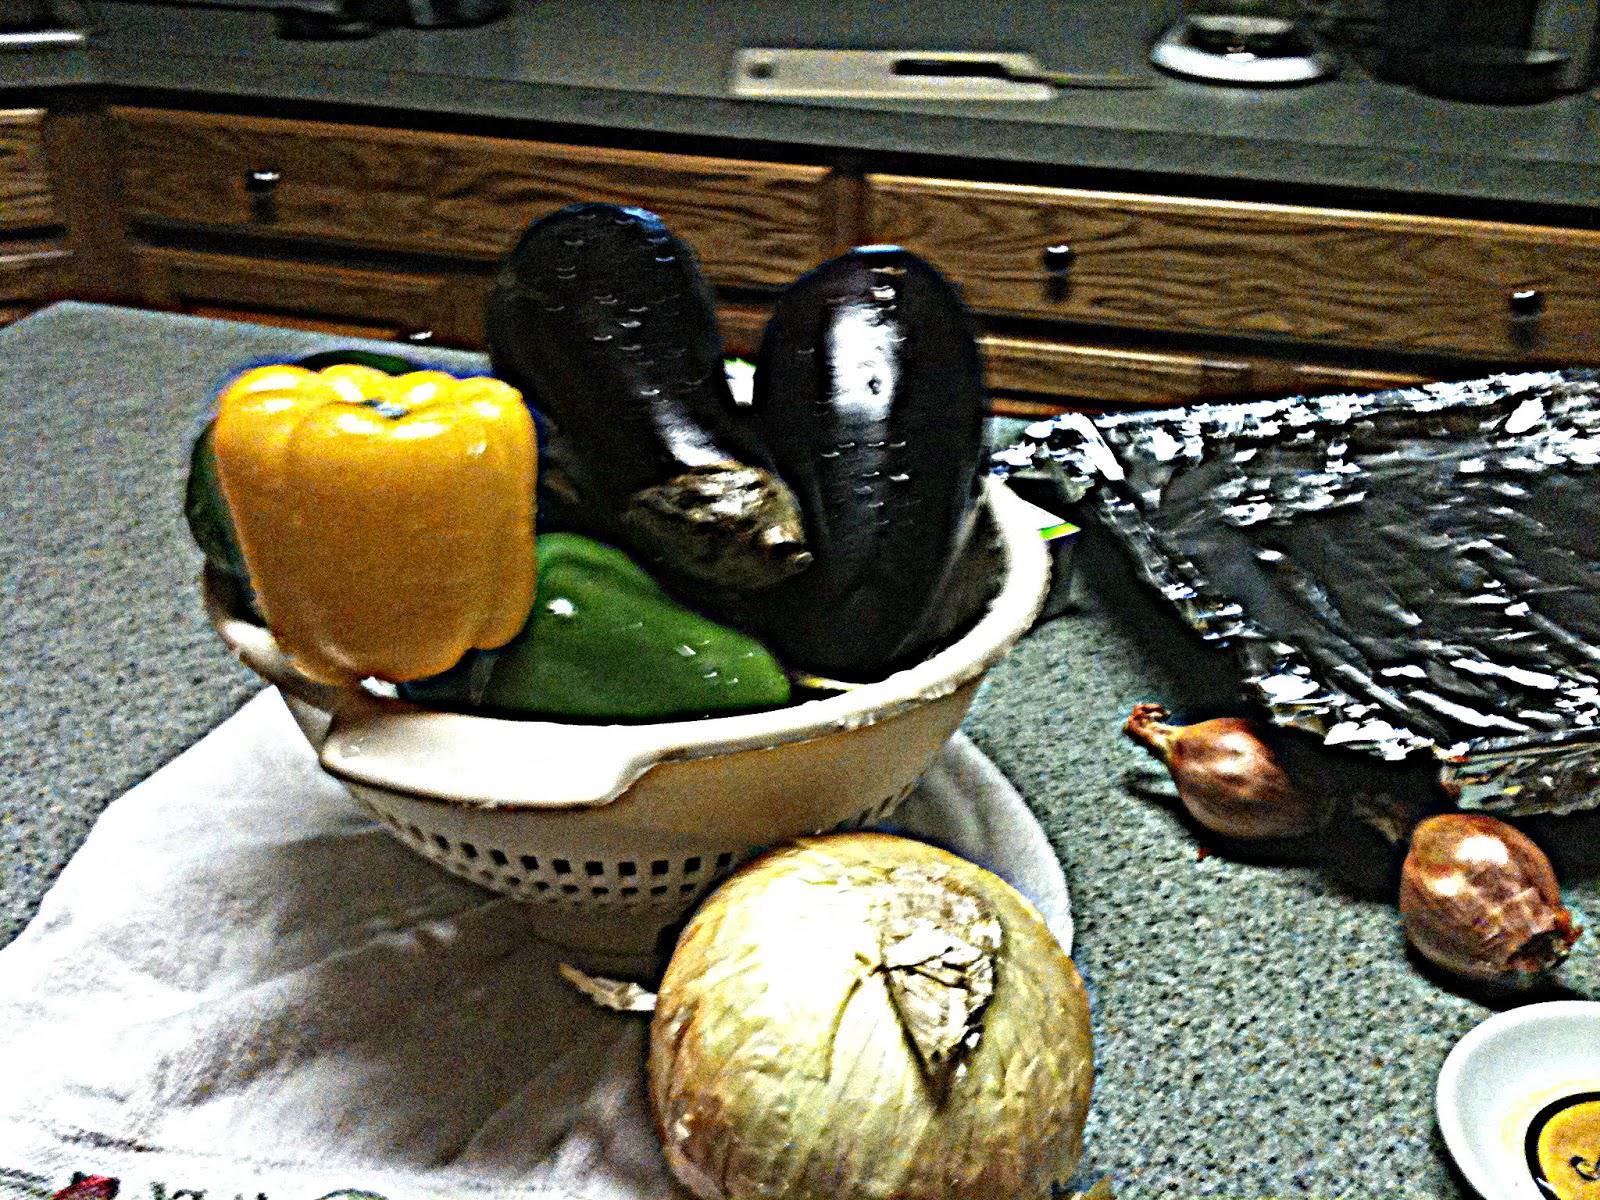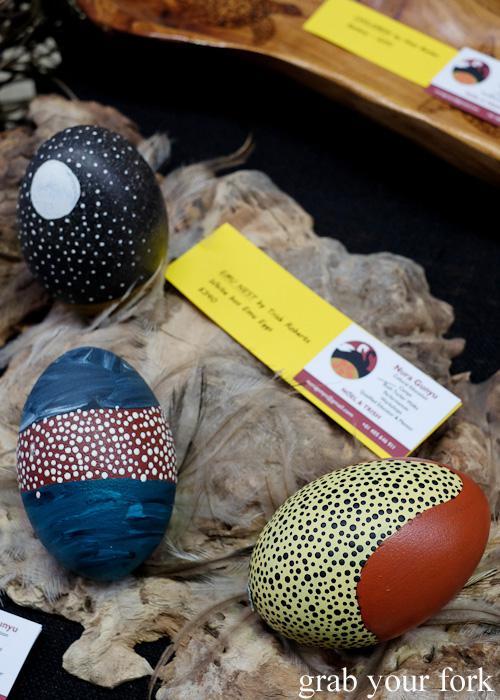The first image is the image on the left, the second image is the image on the right. Given the left and right images, does the statement "Nothing is edible." hold true? Answer yes or no. No. The first image is the image on the left, the second image is the image on the right. For the images shown, is this caption "Each image shows acorn caps made of wrapped twine, and at least one image includes acorns made of plastic eggs in orange, yellow and green colors." true? Answer yes or no. No. 